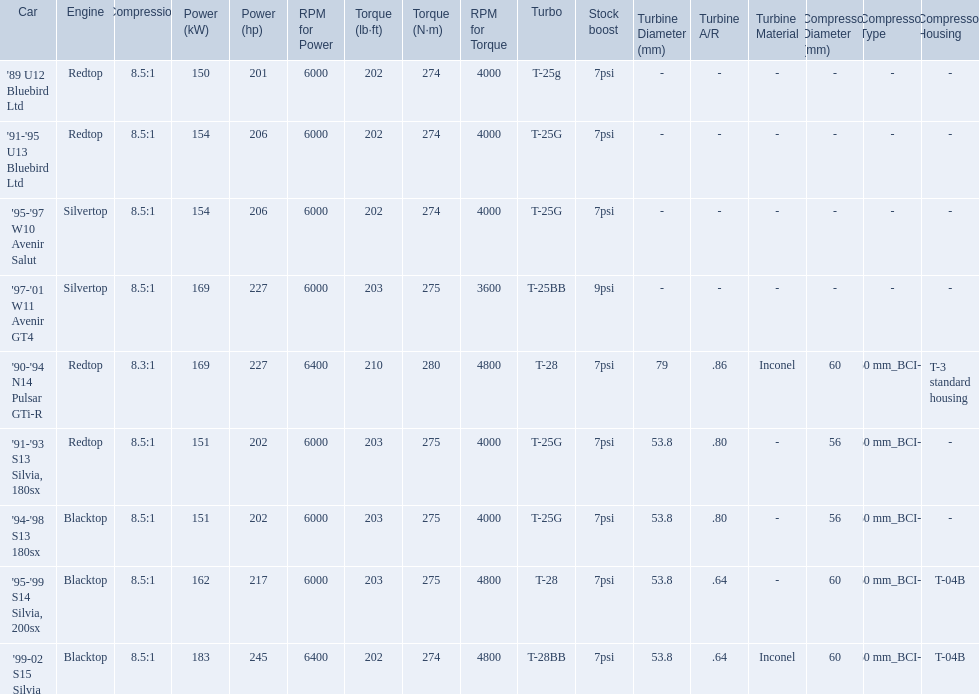What are all of the cars? '89 U12 Bluebird Ltd, '91-'95 U13 Bluebird Ltd, '95-'97 W10 Avenir Salut, '97-'01 W11 Avenir GT4, '90-'94 N14 Pulsar GTi-R, '91-'93 S13 Silvia, 180sx, '94-'98 S13 180sx, '95-'99 S14 Silvia, 200sx, '99-02 S15 Silvia. What is their rated power? 150 kW (201 hp) @ 6000 rpm, 154 kW (206 hp) @ 6000 rpm, 154 kW (206 hp) @ 6000 rpm, 169 kW (227 hp) @ 6000 rpm, 169 kW (227 hp) @ 6400 rpm (Euro: 164 kW (220 hp) @ 6400 rpm), 151 kW (202 hp) @ 6000 rpm, 151 kW (202 hp) @ 6000 rpm, 162 kW (217 hp) @ 6000 rpm, 183 kW (245 hp) @ 6400 rpm. Which car has the most power? '99-02 S15 Silvia. 